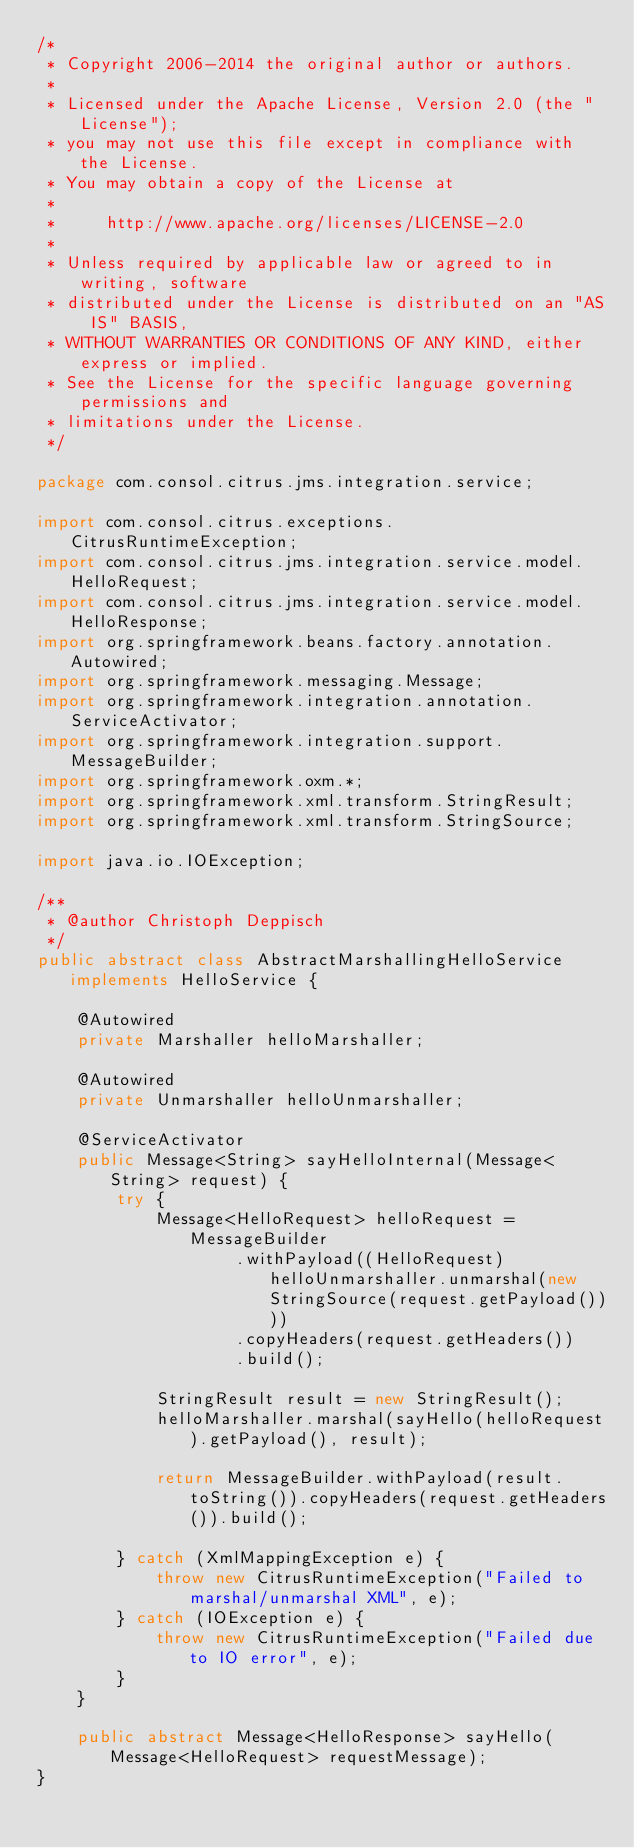<code> <loc_0><loc_0><loc_500><loc_500><_Java_>/*
 * Copyright 2006-2014 the original author or authors.
 *
 * Licensed under the Apache License, Version 2.0 (the "License");
 * you may not use this file except in compliance with the License.
 * You may obtain a copy of the License at
 *
 *     http://www.apache.org/licenses/LICENSE-2.0
 *
 * Unless required by applicable law or agreed to in writing, software
 * distributed under the License is distributed on an "AS IS" BASIS,
 * WITHOUT WARRANTIES OR CONDITIONS OF ANY KIND, either express or implied.
 * See the License for the specific language governing permissions and
 * limitations under the License.
 */

package com.consol.citrus.jms.integration.service;

import com.consol.citrus.exceptions.CitrusRuntimeException;
import com.consol.citrus.jms.integration.service.model.HelloRequest;
import com.consol.citrus.jms.integration.service.model.HelloResponse;
import org.springframework.beans.factory.annotation.Autowired;
import org.springframework.messaging.Message;
import org.springframework.integration.annotation.ServiceActivator;
import org.springframework.integration.support.MessageBuilder;
import org.springframework.oxm.*;
import org.springframework.xml.transform.StringResult;
import org.springframework.xml.transform.StringSource;

import java.io.IOException;

/**
 * @author Christoph Deppisch
 */
public abstract class AbstractMarshallingHelloService implements HelloService {

    @Autowired
    private Marshaller helloMarshaller;
    
    @Autowired
    private Unmarshaller helloUnmarshaller;
    
    @ServiceActivator
    public Message<String> sayHelloInternal(Message<String> request) {
        try {
            Message<HelloRequest> helloRequest = MessageBuilder
                    .withPayload((HelloRequest) helloUnmarshaller.unmarshal(new StringSource(request.getPayload())))
                    .copyHeaders(request.getHeaders())
                    .build();

            StringResult result = new StringResult();
            helloMarshaller.marshal(sayHello(helloRequest).getPayload(), result);
            
            return MessageBuilder.withPayload(result.toString()).copyHeaders(request.getHeaders()).build();
            
        } catch (XmlMappingException e) {
            throw new CitrusRuntimeException("Failed to marshal/unmarshal XML", e);
        } catch (IOException e) {
            throw new CitrusRuntimeException("Failed due to IO error", e);
        }
    }
    
    public abstract Message<HelloResponse> sayHello(Message<HelloRequest> requestMessage);
}
</code> 